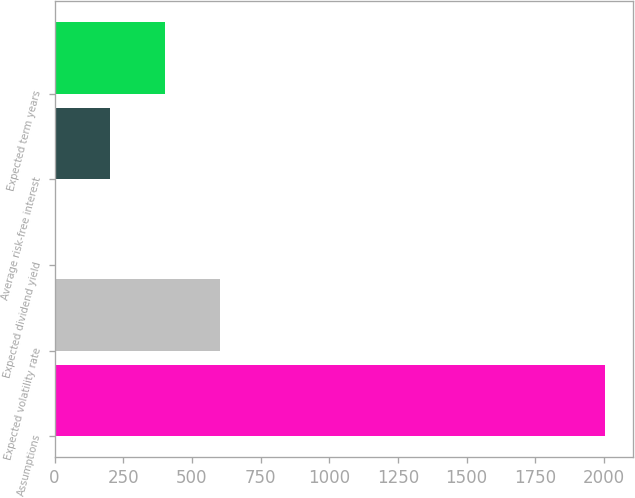Convert chart to OTSL. <chart><loc_0><loc_0><loc_500><loc_500><bar_chart><fcel>Assumptions<fcel>Expected volatility rate<fcel>Expected dividend yield<fcel>Average risk-free interest<fcel>Expected term years<nl><fcel>2005<fcel>603.8<fcel>3.29<fcel>203.46<fcel>403.63<nl></chart> 